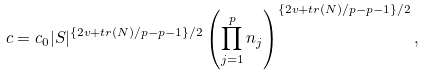Convert formula to latex. <formula><loc_0><loc_0><loc_500><loc_500>c = c _ { 0 } | S | ^ { \left \{ 2 v + t r \left ( N \right ) / p - p - 1 \right \} / 2 } \left ( \prod _ { j = 1 } ^ { p } n _ { j } \right ) ^ { \left \{ 2 v + t r \left ( N \right ) / p - p - 1 \right \} / 2 } ,</formula> 